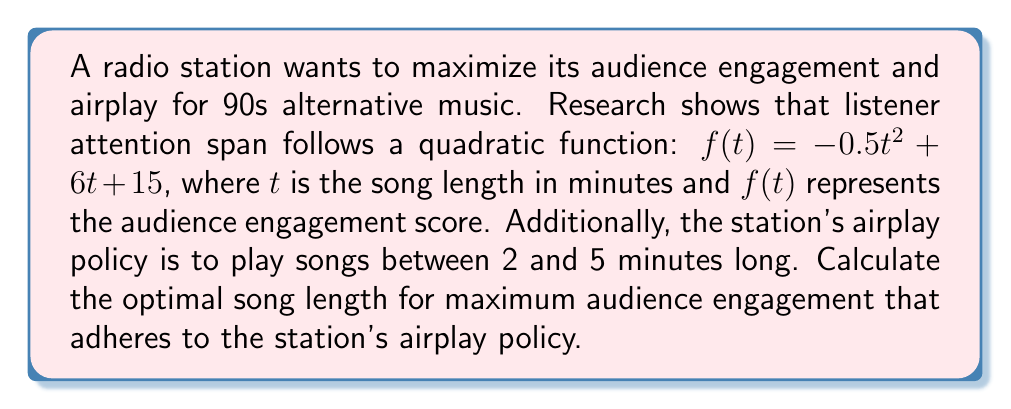What is the answer to this math problem? To solve this optimization problem, we need to follow these steps:

1. Identify the function to maximize:
   $f(t) = -0.5t^2 + 6t + 15$

2. Find the critical points by taking the derivative and setting it to zero:
   $$\frac{df}{dt} = -t + 6$$
   $$-t + 6 = 0$$
   $$t = 6$$

3. Check the endpoints of the interval [2, 5] as potential maximum points:
   $f(2) = -0.5(2)^2 + 6(2) + 15 = 25$
   $f(5) = -0.5(5)^2 + 6(5) + 15 = 27.5$

4. Evaluate the critical point $t = 6$:
   Since 6 is outside the interval [2, 5], it's not a valid solution.

5. Compare the values at the endpoints:
   $f(2) = 25$ and $f(5) = 27.5$

The maximum value occurs at $t = 5$, which is within the station's airplay policy of 2 to 5 minutes.
Answer: The optimal song length for maximum radio airplay and audience engagement is 5 minutes. 